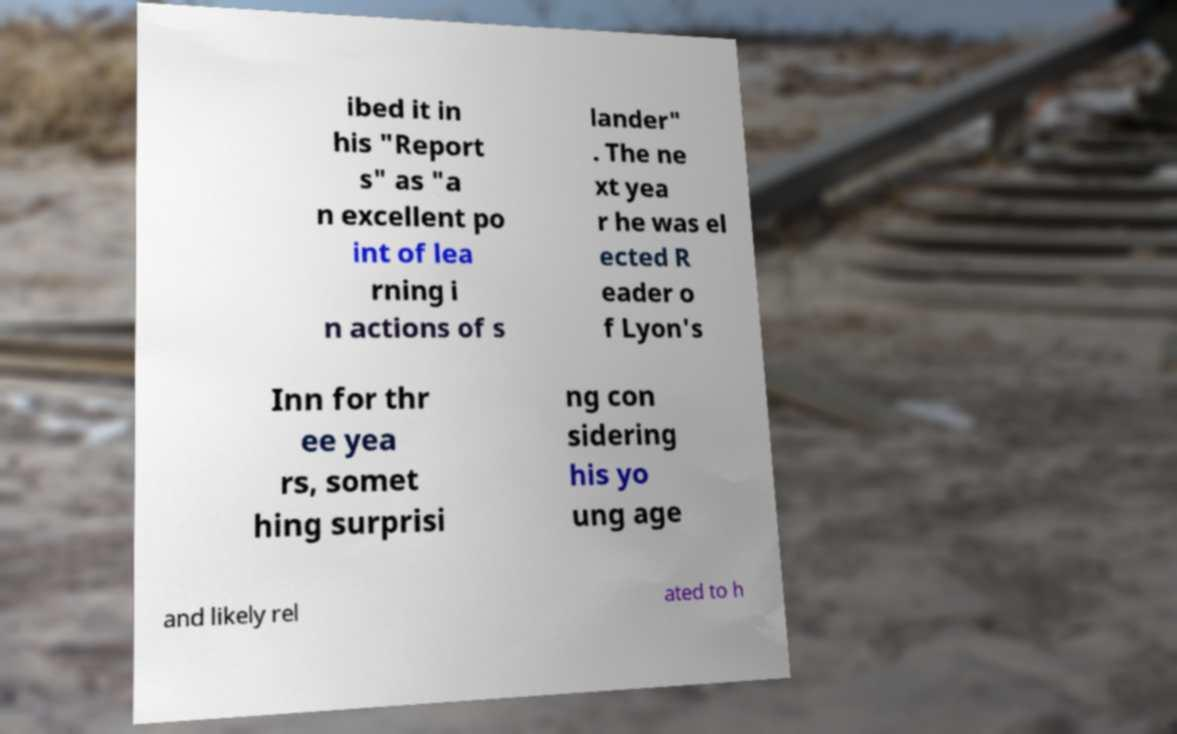I need the written content from this picture converted into text. Can you do that? ibed it in his "Report s" as "a n excellent po int of lea rning i n actions of s lander" . The ne xt yea r he was el ected R eader o f Lyon's Inn for thr ee yea rs, somet hing surprisi ng con sidering his yo ung age and likely rel ated to h 